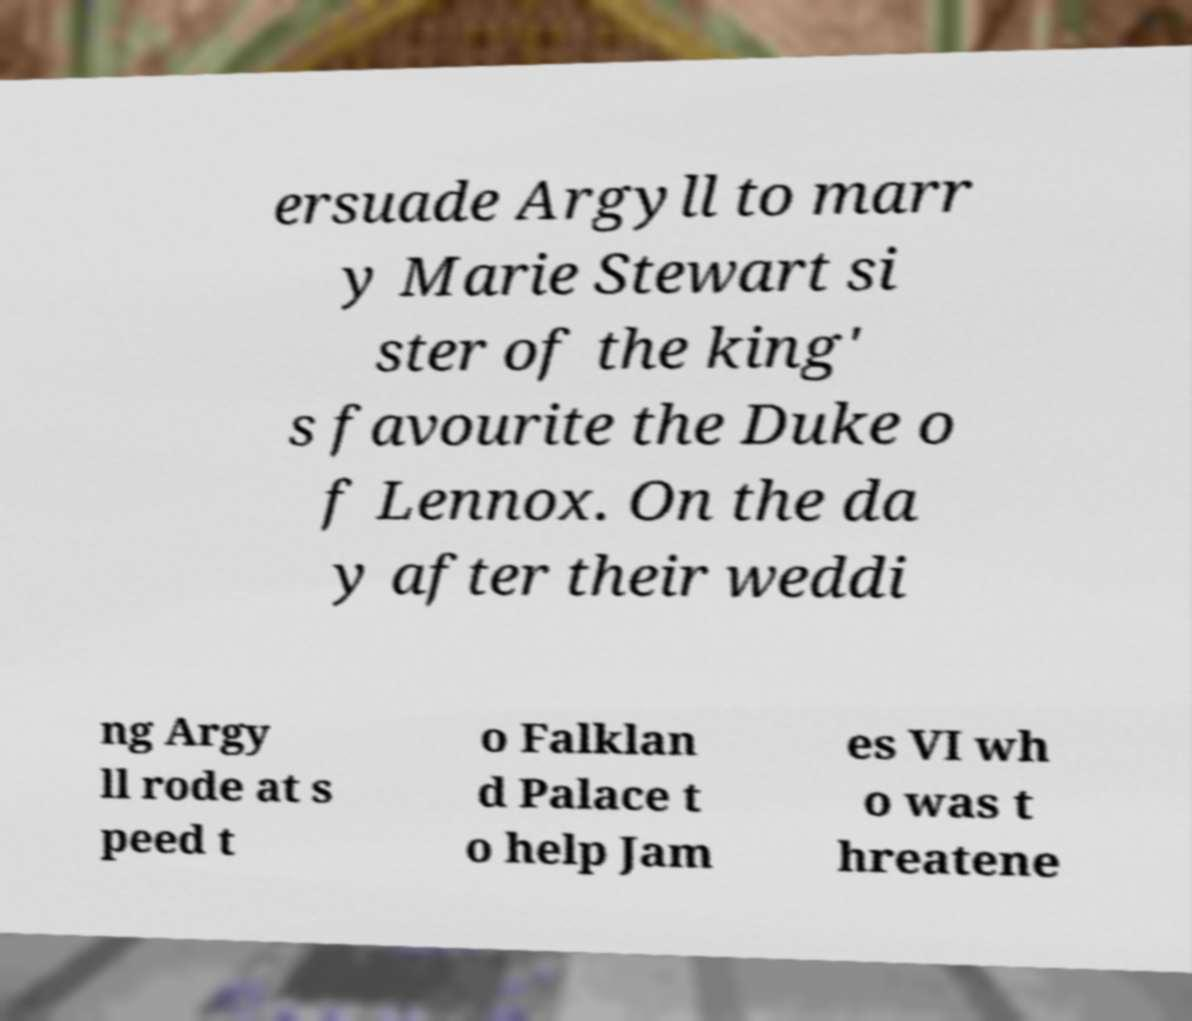For documentation purposes, I need the text within this image transcribed. Could you provide that? ersuade Argyll to marr y Marie Stewart si ster of the king' s favourite the Duke o f Lennox. On the da y after their weddi ng Argy ll rode at s peed t o Falklan d Palace t o help Jam es VI wh o was t hreatene 